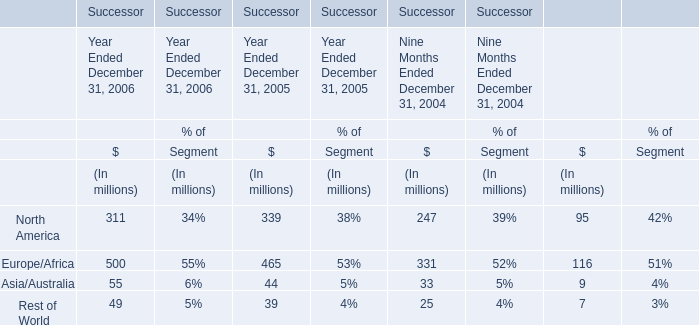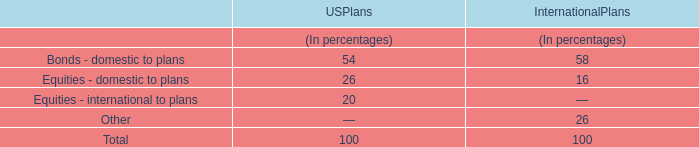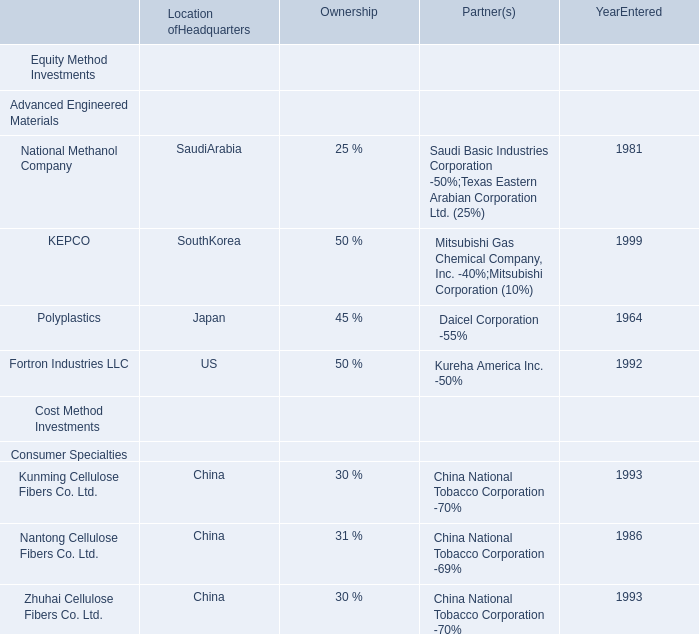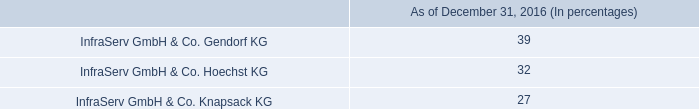what is the net change in the amount spent for research and development in 2015 compare to 2014? 
Computations: (119 - 86)
Answer: 33.0. 